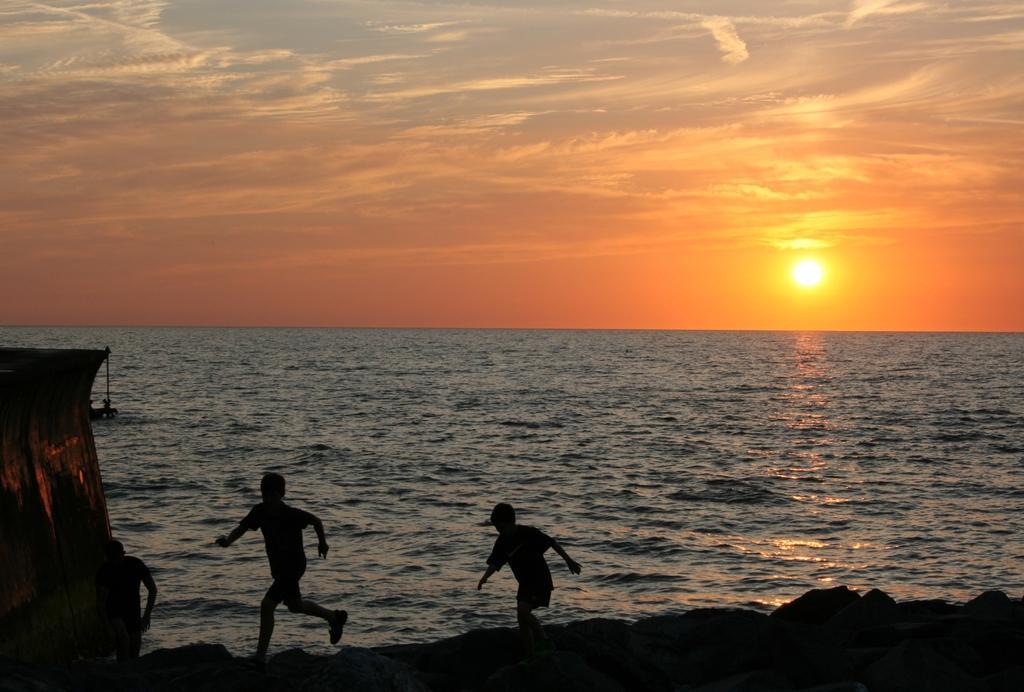Could you give a brief overview of what you see in this image? This image is taken in the evening light. In the center of the image I can see water. At the top of the image I can see the sky with sun. At the bottom of the image I can see three people on rocks. 